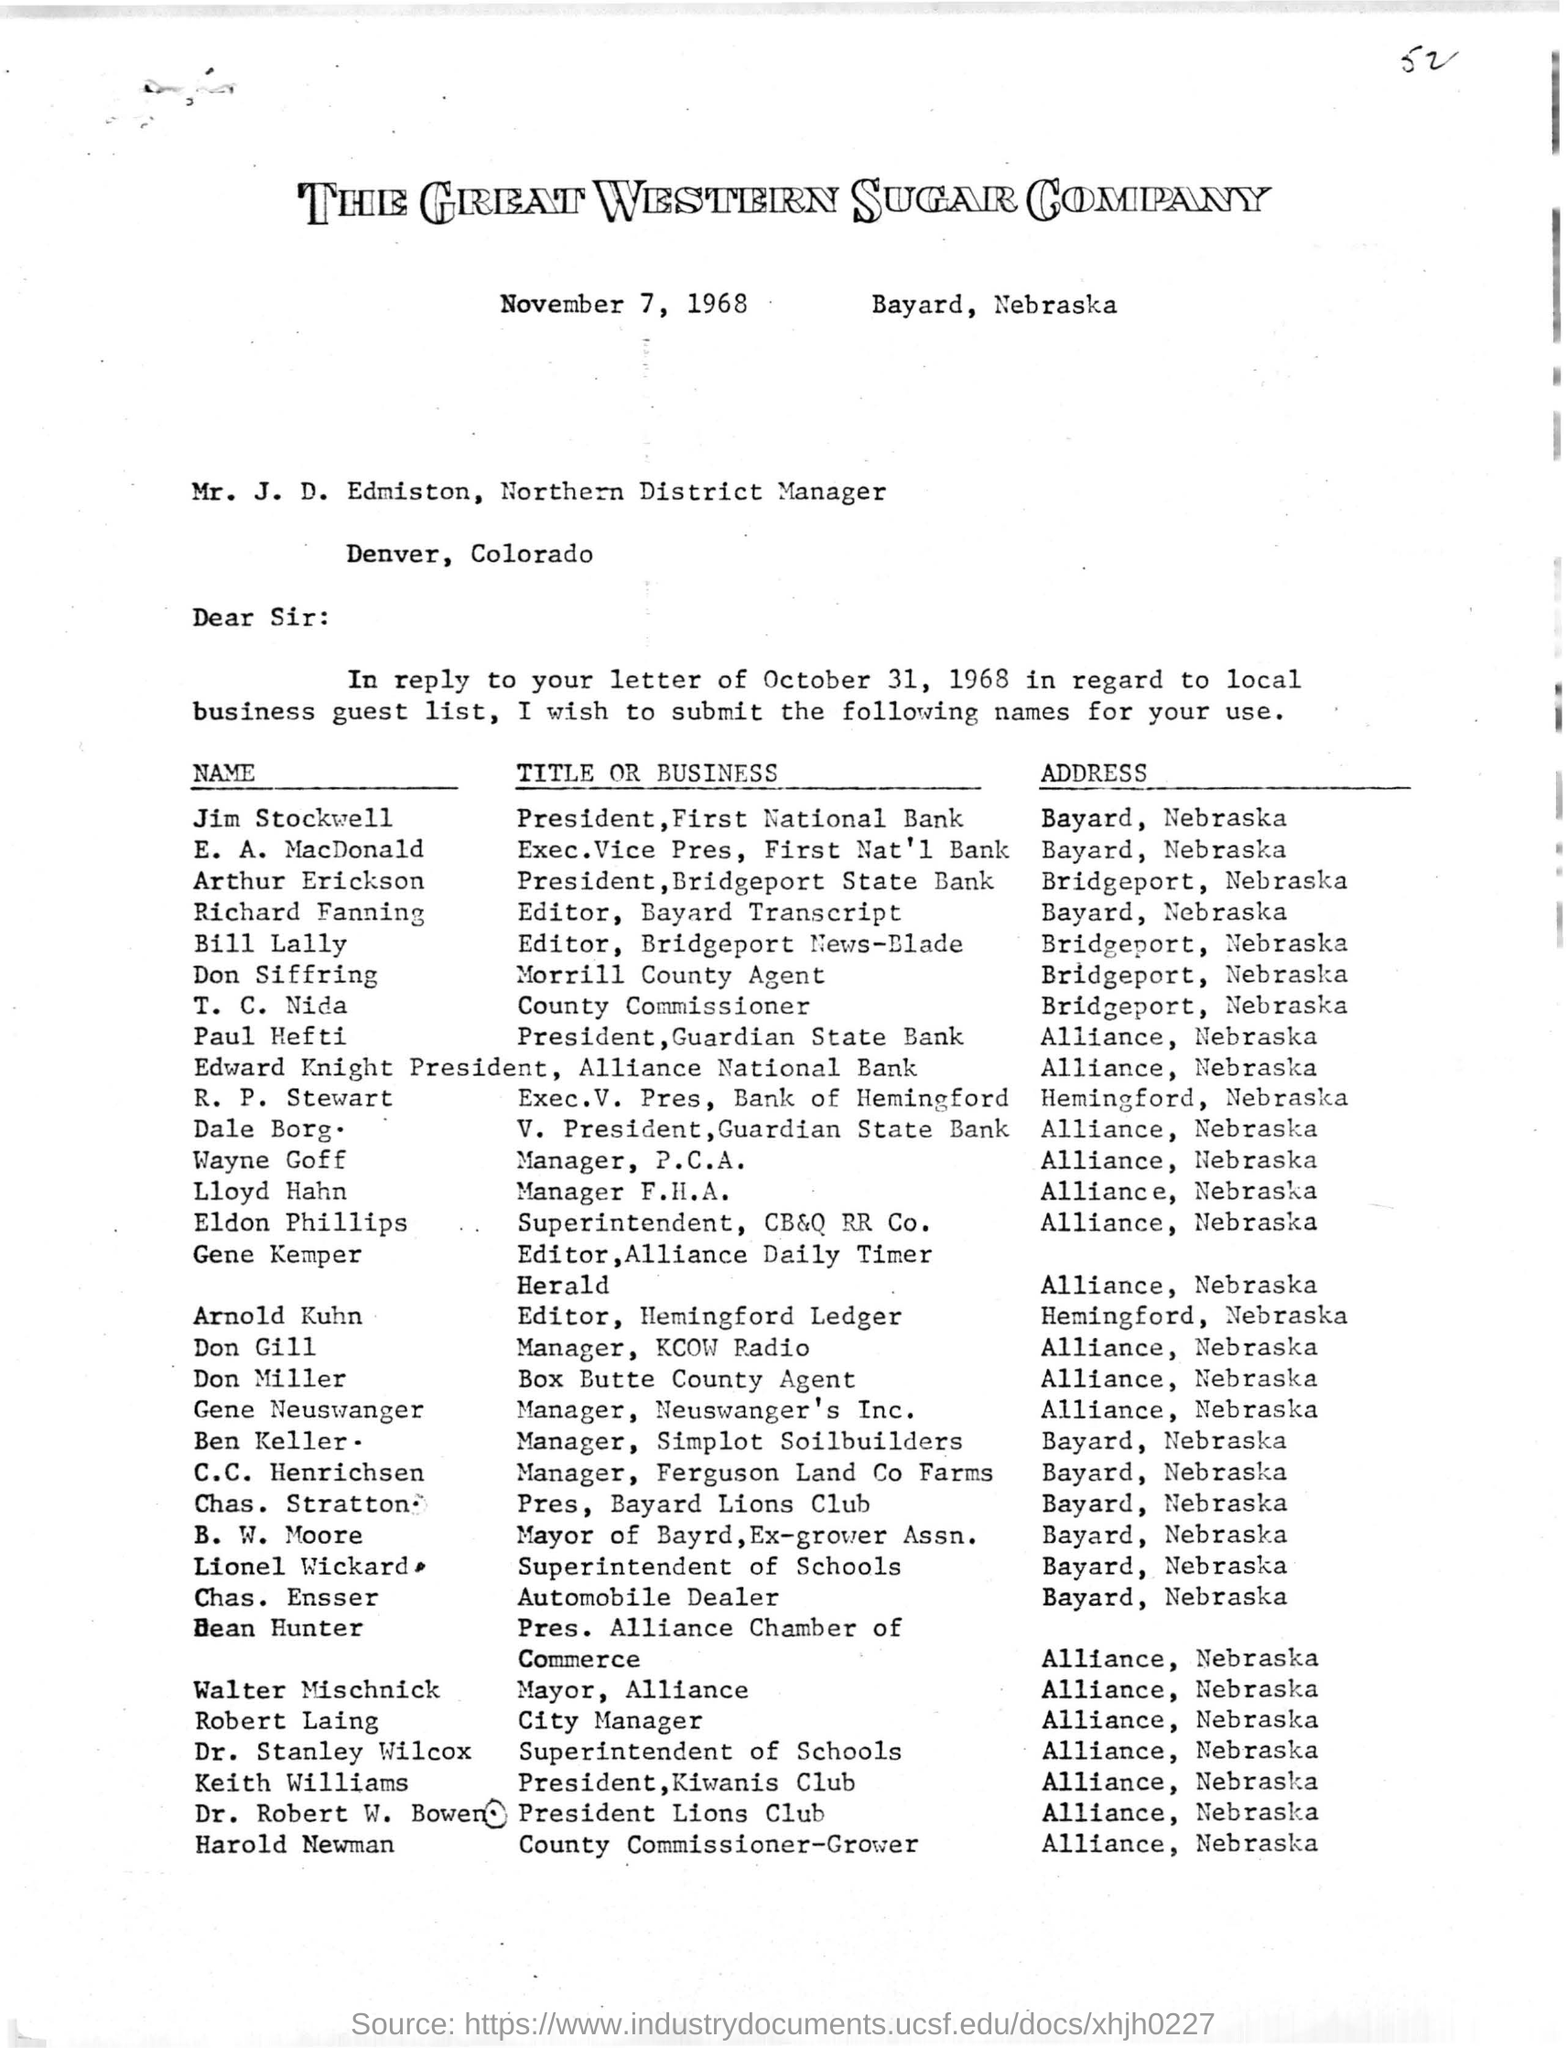Identify some key points in this picture. The Kiwanis Club is located in Alliance, Nebraska. Don Siffring is the Morrill County agent. Jim Stockwell is the President of First National Bank. The date of the letter is November 7, 1968. 